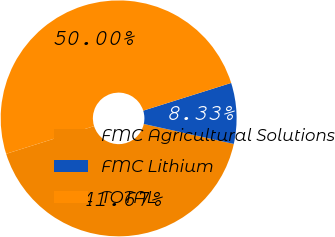<chart> <loc_0><loc_0><loc_500><loc_500><pie_chart><fcel>FMC Agricultural Solutions<fcel>FMC Lithium<fcel>TOTAL<nl><fcel>41.67%<fcel>8.33%<fcel>50.0%<nl></chart> 